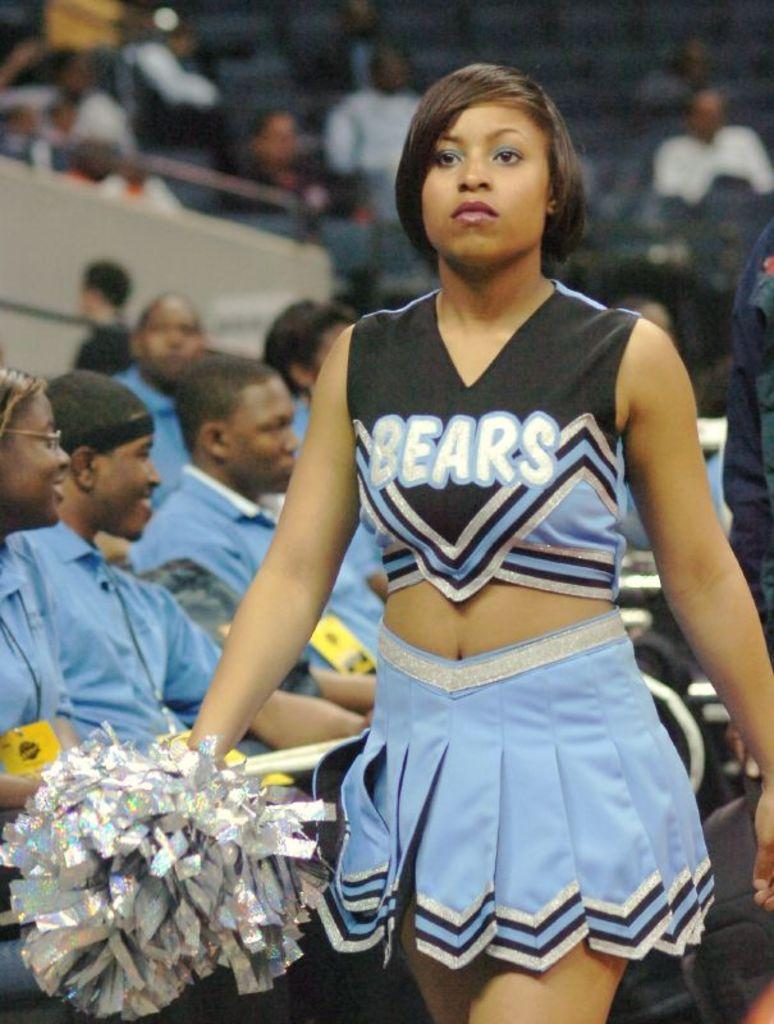<image>
Create a compact narrative representing the image presented. The Bears cheerleader in a baby blue skirt does not look happy. 